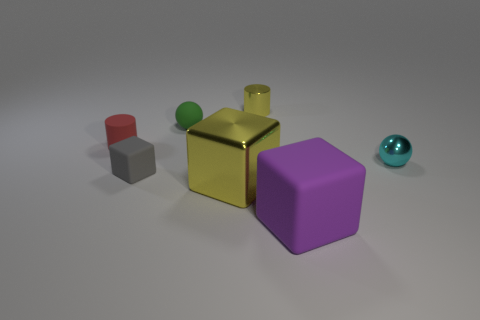There is a tiny thing that is both to the left of the tiny cyan shiny object and to the right of the green matte object; what shape is it?
Offer a terse response. Cylinder. There is a shiny object that is behind the tiny shiny ball; is it the same color as the tiny matte ball?
Give a very brief answer. No. There is a small thing right of the large purple block; is its shape the same as the shiny thing behind the tiny cyan metallic thing?
Provide a succinct answer. No. What is the size of the yellow thing in front of the metal sphere?
Offer a terse response. Large. There is a cylinder to the left of the small ball that is left of the big rubber thing; what size is it?
Make the answer very short. Small. Are there more big yellow cubes than yellow metallic things?
Your answer should be compact. No. Is the number of yellow objects on the left side of the tiny yellow object greater than the number of metallic spheres that are left of the large matte object?
Your answer should be very brief. Yes. There is a metal object that is in front of the tiny green sphere and left of the small cyan thing; how big is it?
Keep it short and to the point. Large. What number of purple blocks have the same size as the purple object?
Provide a succinct answer. 0. What material is the thing that is the same color as the small shiny cylinder?
Your response must be concise. Metal. 